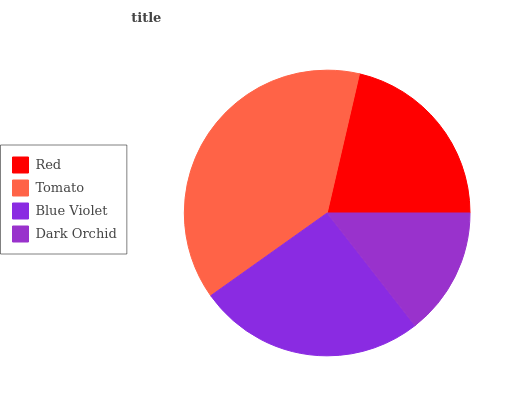Is Dark Orchid the minimum?
Answer yes or no. Yes. Is Tomato the maximum?
Answer yes or no. Yes. Is Blue Violet the minimum?
Answer yes or no. No. Is Blue Violet the maximum?
Answer yes or no. No. Is Tomato greater than Blue Violet?
Answer yes or no. Yes. Is Blue Violet less than Tomato?
Answer yes or no. Yes. Is Blue Violet greater than Tomato?
Answer yes or no. No. Is Tomato less than Blue Violet?
Answer yes or no. No. Is Blue Violet the high median?
Answer yes or no. Yes. Is Red the low median?
Answer yes or no. Yes. Is Dark Orchid the high median?
Answer yes or no. No. Is Dark Orchid the low median?
Answer yes or no. No. 